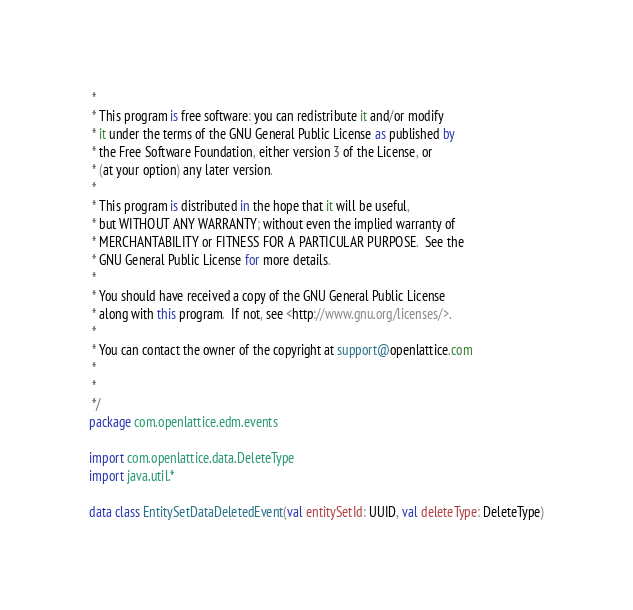<code> <loc_0><loc_0><loc_500><loc_500><_Kotlin_> *
 * This program is free software: you can redistribute it and/or modify
 * it under the terms of the GNU General Public License as published by
 * the Free Software Foundation, either version 3 of the License, or
 * (at your option) any later version.
 *
 * This program is distributed in the hope that it will be useful,
 * but WITHOUT ANY WARRANTY; without even the implied warranty of
 * MERCHANTABILITY or FITNESS FOR A PARTICULAR PURPOSE.  See the
 * GNU General Public License for more details.
 *
 * You should have received a copy of the GNU General Public License
 * along with this program.  If not, see <http://www.gnu.org/licenses/>.
 *
 * You can contact the owner of the copyright at support@openlattice.com
 *
 *
 */
package com.openlattice.edm.events

import com.openlattice.data.DeleteType
import java.util.*

data class EntitySetDataDeletedEvent(val entitySetId: UUID, val deleteType: DeleteType)</code> 